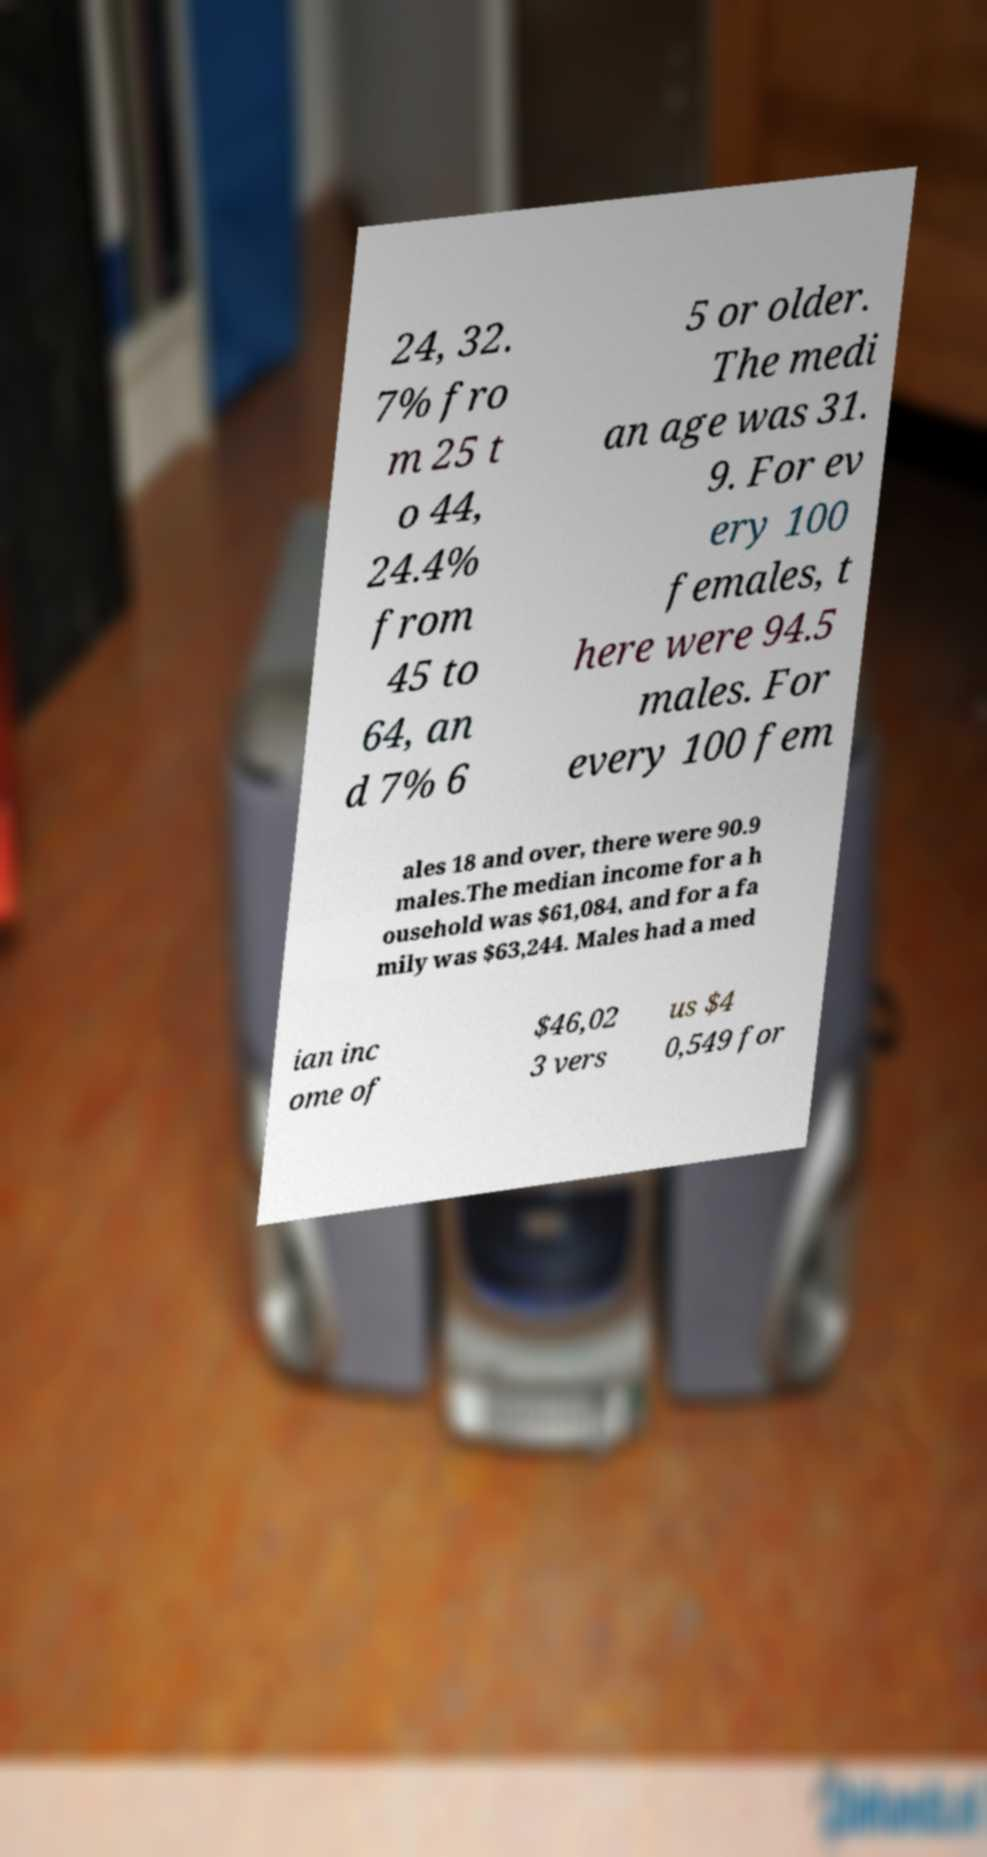Could you extract and type out the text from this image? 24, 32. 7% fro m 25 t o 44, 24.4% from 45 to 64, an d 7% 6 5 or older. The medi an age was 31. 9. For ev ery 100 females, t here were 94.5 males. For every 100 fem ales 18 and over, there were 90.9 males.The median income for a h ousehold was $61,084, and for a fa mily was $63,244. Males had a med ian inc ome of $46,02 3 vers us $4 0,549 for 